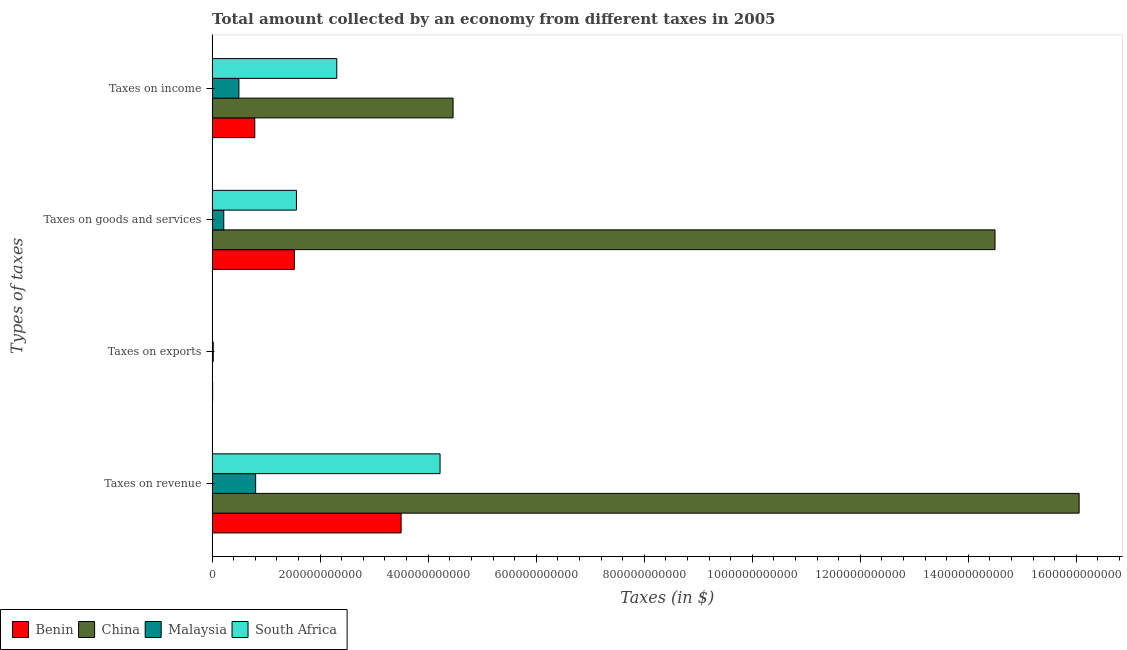How many different coloured bars are there?
Ensure brevity in your answer.  4. Are the number of bars on each tick of the Y-axis equal?
Offer a terse response. No. What is the label of the 1st group of bars from the top?
Give a very brief answer. Taxes on income. What is the amount collected as tax on income in South Africa?
Give a very brief answer. 2.31e+11. Across all countries, what is the maximum amount collected as tax on exports?
Give a very brief answer. 2.08e+09. Across all countries, what is the minimum amount collected as tax on exports?
Offer a very short reply. 0. In which country was the amount collected as tax on exports maximum?
Provide a short and direct response. Malaysia. What is the total amount collected as tax on revenue in the graph?
Your answer should be very brief. 2.46e+12. What is the difference between the amount collected as tax on revenue in South Africa and that in Benin?
Your answer should be compact. 7.21e+1. What is the difference between the amount collected as tax on income in Malaysia and the amount collected as tax on exports in Benin?
Your response must be concise. 4.87e+1. What is the average amount collected as tax on income per country?
Your answer should be compact. 2.01e+11. What is the difference between the amount collected as tax on exports and amount collected as tax on income in Benin?
Provide a succinct answer. -7.81e+1. What is the ratio of the amount collected as tax on revenue in Benin to that in South Africa?
Offer a very short reply. 0.83. Is the amount collected as tax on revenue in China less than that in South Africa?
Your answer should be very brief. No. What is the difference between the highest and the second highest amount collected as tax on revenue?
Your response must be concise. 1.18e+12. What is the difference between the highest and the lowest amount collected as tax on revenue?
Provide a short and direct response. 1.52e+12. Is the sum of the amount collected as tax on income in Benin and South Africa greater than the maximum amount collected as tax on revenue across all countries?
Make the answer very short. No. Is it the case that in every country, the sum of the amount collected as tax on goods and amount collected as tax on income is greater than the sum of amount collected as tax on exports and amount collected as tax on revenue?
Provide a short and direct response. No. Is it the case that in every country, the sum of the amount collected as tax on revenue and amount collected as tax on exports is greater than the amount collected as tax on goods?
Offer a terse response. Yes. What is the difference between two consecutive major ticks on the X-axis?
Offer a terse response. 2.00e+11. Are the values on the major ticks of X-axis written in scientific E-notation?
Provide a succinct answer. No. Does the graph contain grids?
Keep it short and to the point. No. Where does the legend appear in the graph?
Your answer should be very brief. Bottom left. How many legend labels are there?
Your response must be concise. 4. How are the legend labels stacked?
Your answer should be compact. Horizontal. What is the title of the graph?
Your answer should be compact. Total amount collected by an economy from different taxes in 2005. What is the label or title of the X-axis?
Your answer should be compact. Taxes (in $). What is the label or title of the Y-axis?
Provide a short and direct response. Types of taxes. What is the Taxes (in $) in Benin in Taxes on revenue?
Keep it short and to the point. 3.50e+11. What is the Taxes (in $) in China in Taxes on revenue?
Offer a terse response. 1.61e+12. What is the Taxes (in $) in Malaysia in Taxes on revenue?
Provide a succinct answer. 8.06e+1. What is the Taxes (in $) of South Africa in Taxes on revenue?
Keep it short and to the point. 4.22e+11. What is the Taxes (in $) of Benin in Taxes on exports?
Your answer should be compact. 9.19e+08. What is the Taxes (in $) in Malaysia in Taxes on exports?
Provide a succinct answer. 2.08e+09. What is the Taxes (in $) in South Africa in Taxes on exports?
Provide a succinct answer. 1.00e+06. What is the Taxes (in $) in Benin in Taxes on goods and services?
Provide a short and direct response. 1.52e+11. What is the Taxes (in $) of China in Taxes on goods and services?
Offer a terse response. 1.45e+12. What is the Taxes (in $) in Malaysia in Taxes on goods and services?
Your answer should be compact. 2.16e+1. What is the Taxes (in $) in South Africa in Taxes on goods and services?
Your answer should be compact. 1.56e+11. What is the Taxes (in $) of Benin in Taxes on income?
Your answer should be compact. 7.90e+1. What is the Taxes (in $) of China in Taxes on income?
Your answer should be compact. 4.46e+11. What is the Taxes (in $) in Malaysia in Taxes on income?
Make the answer very short. 4.96e+1. What is the Taxes (in $) in South Africa in Taxes on income?
Offer a terse response. 2.31e+11. Across all Types of taxes, what is the maximum Taxes (in $) of Benin?
Your response must be concise. 3.50e+11. Across all Types of taxes, what is the maximum Taxes (in $) of China?
Offer a terse response. 1.61e+12. Across all Types of taxes, what is the maximum Taxes (in $) in Malaysia?
Offer a terse response. 8.06e+1. Across all Types of taxes, what is the maximum Taxes (in $) of South Africa?
Your response must be concise. 4.22e+11. Across all Types of taxes, what is the minimum Taxes (in $) in Benin?
Offer a very short reply. 9.19e+08. Across all Types of taxes, what is the minimum Taxes (in $) of Malaysia?
Provide a succinct answer. 2.08e+09. Across all Types of taxes, what is the minimum Taxes (in $) in South Africa?
Ensure brevity in your answer.  1.00e+06. What is the total Taxes (in $) in Benin in the graph?
Offer a very short reply. 5.82e+11. What is the total Taxes (in $) of China in the graph?
Provide a succinct answer. 3.50e+12. What is the total Taxes (in $) in Malaysia in the graph?
Give a very brief answer. 1.54e+11. What is the total Taxes (in $) in South Africa in the graph?
Your answer should be very brief. 8.09e+11. What is the difference between the Taxes (in $) in Benin in Taxes on revenue and that in Taxes on exports?
Your answer should be compact. 3.49e+11. What is the difference between the Taxes (in $) of Malaysia in Taxes on revenue and that in Taxes on exports?
Provide a succinct answer. 7.85e+1. What is the difference between the Taxes (in $) in South Africa in Taxes on revenue and that in Taxes on exports?
Offer a very short reply. 4.22e+11. What is the difference between the Taxes (in $) in Benin in Taxes on revenue and that in Taxes on goods and services?
Offer a terse response. 1.98e+11. What is the difference between the Taxes (in $) of China in Taxes on revenue and that in Taxes on goods and services?
Your response must be concise. 1.56e+11. What is the difference between the Taxes (in $) in Malaysia in Taxes on revenue and that in Taxes on goods and services?
Provide a short and direct response. 5.90e+1. What is the difference between the Taxes (in $) in South Africa in Taxes on revenue and that in Taxes on goods and services?
Offer a terse response. 2.66e+11. What is the difference between the Taxes (in $) of Benin in Taxes on revenue and that in Taxes on income?
Your answer should be compact. 2.71e+11. What is the difference between the Taxes (in $) of China in Taxes on revenue and that in Taxes on income?
Make the answer very short. 1.16e+12. What is the difference between the Taxes (in $) in Malaysia in Taxes on revenue and that in Taxes on income?
Your answer should be very brief. 3.10e+1. What is the difference between the Taxes (in $) of South Africa in Taxes on revenue and that in Taxes on income?
Ensure brevity in your answer.  1.91e+11. What is the difference between the Taxes (in $) of Benin in Taxes on exports and that in Taxes on goods and services?
Give a very brief answer. -1.51e+11. What is the difference between the Taxes (in $) in Malaysia in Taxes on exports and that in Taxes on goods and services?
Ensure brevity in your answer.  -1.95e+1. What is the difference between the Taxes (in $) of South Africa in Taxes on exports and that in Taxes on goods and services?
Your answer should be compact. -1.56e+11. What is the difference between the Taxes (in $) of Benin in Taxes on exports and that in Taxes on income?
Make the answer very short. -7.81e+1. What is the difference between the Taxes (in $) in Malaysia in Taxes on exports and that in Taxes on income?
Keep it short and to the point. -4.75e+1. What is the difference between the Taxes (in $) of South Africa in Taxes on exports and that in Taxes on income?
Provide a short and direct response. -2.31e+11. What is the difference between the Taxes (in $) of Benin in Taxes on goods and services and that in Taxes on income?
Offer a terse response. 7.32e+1. What is the difference between the Taxes (in $) in China in Taxes on goods and services and that in Taxes on income?
Offer a very short reply. 1.00e+12. What is the difference between the Taxes (in $) in Malaysia in Taxes on goods and services and that in Taxes on income?
Offer a terse response. -2.80e+1. What is the difference between the Taxes (in $) in South Africa in Taxes on goods and services and that in Taxes on income?
Make the answer very short. -7.47e+1. What is the difference between the Taxes (in $) of Benin in Taxes on revenue and the Taxes (in $) of Malaysia in Taxes on exports?
Offer a very short reply. 3.48e+11. What is the difference between the Taxes (in $) of Benin in Taxes on revenue and the Taxes (in $) of South Africa in Taxes on exports?
Provide a succinct answer. 3.50e+11. What is the difference between the Taxes (in $) in China in Taxes on revenue and the Taxes (in $) in Malaysia in Taxes on exports?
Provide a succinct answer. 1.60e+12. What is the difference between the Taxes (in $) of China in Taxes on revenue and the Taxes (in $) of South Africa in Taxes on exports?
Provide a succinct answer. 1.61e+12. What is the difference between the Taxes (in $) of Malaysia in Taxes on revenue and the Taxes (in $) of South Africa in Taxes on exports?
Give a very brief answer. 8.06e+1. What is the difference between the Taxes (in $) of Benin in Taxes on revenue and the Taxes (in $) of China in Taxes on goods and services?
Your answer should be compact. -1.10e+12. What is the difference between the Taxes (in $) in Benin in Taxes on revenue and the Taxes (in $) in Malaysia in Taxes on goods and services?
Make the answer very short. 3.28e+11. What is the difference between the Taxes (in $) of Benin in Taxes on revenue and the Taxes (in $) of South Africa in Taxes on goods and services?
Keep it short and to the point. 1.94e+11. What is the difference between the Taxes (in $) in China in Taxes on revenue and the Taxes (in $) in Malaysia in Taxes on goods and services?
Your answer should be compact. 1.58e+12. What is the difference between the Taxes (in $) in China in Taxes on revenue and the Taxes (in $) in South Africa in Taxes on goods and services?
Give a very brief answer. 1.45e+12. What is the difference between the Taxes (in $) of Malaysia in Taxes on revenue and the Taxes (in $) of South Africa in Taxes on goods and services?
Provide a succinct answer. -7.55e+1. What is the difference between the Taxes (in $) in Benin in Taxes on revenue and the Taxes (in $) in China in Taxes on income?
Keep it short and to the point. -9.62e+1. What is the difference between the Taxes (in $) in Benin in Taxes on revenue and the Taxes (in $) in Malaysia in Taxes on income?
Offer a terse response. 3.00e+11. What is the difference between the Taxes (in $) in Benin in Taxes on revenue and the Taxes (in $) in South Africa in Taxes on income?
Offer a terse response. 1.19e+11. What is the difference between the Taxes (in $) in China in Taxes on revenue and the Taxes (in $) in Malaysia in Taxes on income?
Ensure brevity in your answer.  1.56e+12. What is the difference between the Taxes (in $) of China in Taxes on revenue and the Taxes (in $) of South Africa in Taxes on income?
Your response must be concise. 1.37e+12. What is the difference between the Taxes (in $) in Malaysia in Taxes on revenue and the Taxes (in $) in South Africa in Taxes on income?
Give a very brief answer. -1.50e+11. What is the difference between the Taxes (in $) of Benin in Taxes on exports and the Taxes (in $) of China in Taxes on goods and services?
Your answer should be very brief. -1.45e+12. What is the difference between the Taxes (in $) of Benin in Taxes on exports and the Taxes (in $) of Malaysia in Taxes on goods and services?
Keep it short and to the point. -2.07e+1. What is the difference between the Taxes (in $) in Benin in Taxes on exports and the Taxes (in $) in South Africa in Taxes on goods and services?
Ensure brevity in your answer.  -1.55e+11. What is the difference between the Taxes (in $) in Malaysia in Taxes on exports and the Taxes (in $) in South Africa in Taxes on goods and services?
Make the answer very short. -1.54e+11. What is the difference between the Taxes (in $) of Benin in Taxes on exports and the Taxes (in $) of China in Taxes on income?
Your response must be concise. -4.45e+11. What is the difference between the Taxes (in $) of Benin in Taxes on exports and the Taxes (in $) of Malaysia in Taxes on income?
Offer a very short reply. -4.87e+1. What is the difference between the Taxes (in $) of Benin in Taxes on exports and the Taxes (in $) of South Africa in Taxes on income?
Your response must be concise. -2.30e+11. What is the difference between the Taxes (in $) of Malaysia in Taxes on exports and the Taxes (in $) of South Africa in Taxes on income?
Your answer should be very brief. -2.29e+11. What is the difference between the Taxes (in $) of Benin in Taxes on goods and services and the Taxes (in $) of China in Taxes on income?
Your answer should be very brief. -2.94e+11. What is the difference between the Taxes (in $) of Benin in Taxes on goods and services and the Taxes (in $) of Malaysia in Taxes on income?
Provide a short and direct response. 1.03e+11. What is the difference between the Taxes (in $) in Benin in Taxes on goods and services and the Taxes (in $) in South Africa in Taxes on income?
Keep it short and to the point. -7.86e+1. What is the difference between the Taxes (in $) of China in Taxes on goods and services and the Taxes (in $) of Malaysia in Taxes on income?
Give a very brief answer. 1.40e+12. What is the difference between the Taxes (in $) of China in Taxes on goods and services and the Taxes (in $) of South Africa in Taxes on income?
Provide a short and direct response. 1.22e+12. What is the difference between the Taxes (in $) of Malaysia in Taxes on goods and services and the Taxes (in $) of South Africa in Taxes on income?
Your answer should be compact. -2.09e+11. What is the average Taxes (in $) in Benin per Types of taxes?
Your answer should be very brief. 1.46e+11. What is the average Taxes (in $) in China per Types of taxes?
Keep it short and to the point. 8.75e+11. What is the average Taxes (in $) in Malaysia per Types of taxes?
Offer a terse response. 3.85e+1. What is the average Taxes (in $) of South Africa per Types of taxes?
Keep it short and to the point. 2.02e+11. What is the difference between the Taxes (in $) in Benin and Taxes (in $) in China in Taxes on revenue?
Ensure brevity in your answer.  -1.26e+12. What is the difference between the Taxes (in $) of Benin and Taxes (in $) of Malaysia in Taxes on revenue?
Provide a succinct answer. 2.69e+11. What is the difference between the Taxes (in $) of Benin and Taxes (in $) of South Africa in Taxes on revenue?
Offer a terse response. -7.21e+1. What is the difference between the Taxes (in $) in China and Taxes (in $) in Malaysia in Taxes on revenue?
Ensure brevity in your answer.  1.52e+12. What is the difference between the Taxes (in $) of China and Taxes (in $) of South Africa in Taxes on revenue?
Offer a very short reply. 1.18e+12. What is the difference between the Taxes (in $) of Malaysia and Taxes (in $) of South Africa in Taxes on revenue?
Provide a succinct answer. -3.41e+11. What is the difference between the Taxes (in $) in Benin and Taxes (in $) in Malaysia in Taxes on exports?
Offer a very short reply. -1.17e+09. What is the difference between the Taxes (in $) of Benin and Taxes (in $) of South Africa in Taxes on exports?
Make the answer very short. 9.18e+08. What is the difference between the Taxes (in $) of Malaysia and Taxes (in $) of South Africa in Taxes on exports?
Your response must be concise. 2.08e+09. What is the difference between the Taxes (in $) in Benin and Taxes (in $) in China in Taxes on goods and services?
Your answer should be very brief. -1.30e+12. What is the difference between the Taxes (in $) of Benin and Taxes (in $) of Malaysia in Taxes on goods and services?
Your response must be concise. 1.31e+11. What is the difference between the Taxes (in $) in Benin and Taxes (in $) in South Africa in Taxes on goods and services?
Provide a short and direct response. -3.89e+09. What is the difference between the Taxes (in $) in China and Taxes (in $) in Malaysia in Taxes on goods and services?
Your response must be concise. 1.43e+12. What is the difference between the Taxes (in $) of China and Taxes (in $) of South Africa in Taxes on goods and services?
Ensure brevity in your answer.  1.29e+12. What is the difference between the Taxes (in $) of Malaysia and Taxes (in $) of South Africa in Taxes on goods and services?
Ensure brevity in your answer.  -1.35e+11. What is the difference between the Taxes (in $) in Benin and Taxes (in $) in China in Taxes on income?
Your answer should be very brief. -3.67e+11. What is the difference between the Taxes (in $) of Benin and Taxes (in $) of Malaysia in Taxes on income?
Offer a terse response. 2.94e+1. What is the difference between the Taxes (in $) of Benin and Taxes (in $) of South Africa in Taxes on income?
Keep it short and to the point. -1.52e+11. What is the difference between the Taxes (in $) of China and Taxes (in $) of Malaysia in Taxes on income?
Offer a very short reply. 3.97e+11. What is the difference between the Taxes (in $) in China and Taxes (in $) in South Africa in Taxes on income?
Offer a very short reply. 2.15e+11. What is the difference between the Taxes (in $) of Malaysia and Taxes (in $) of South Africa in Taxes on income?
Provide a succinct answer. -1.81e+11. What is the ratio of the Taxes (in $) of Benin in Taxes on revenue to that in Taxes on exports?
Provide a short and direct response. 380.65. What is the ratio of the Taxes (in $) in Malaysia in Taxes on revenue to that in Taxes on exports?
Offer a terse response. 38.65. What is the ratio of the Taxes (in $) in South Africa in Taxes on revenue to that in Taxes on exports?
Ensure brevity in your answer.  4.22e+05. What is the ratio of the Taxes (in $) in Benin in Taxes on revenue to that in Taxes on goods and services?
Offer a terse response. 2.3. What is the ratio of the Taxes (in $) in China in Taxes on revenue to that in Taxes on goods and services?
Your response must be concise. 1.11. What is the ratio of the Taxes (in $) of Malaysia in Taxes on revenue to that in Taxes on goods and services?
Your response must be concise. 3.73. What is the ratio of the Taxes (in $) of South Africa in Taxes on revenue to that in Taxes on goods and services?
Your answer should be very brief. 2.7. What is the ratio of the Taxes (in $) in Benin in Taxes on revenue to that in Taxes on income?
Your answer should be very brief. 4.43. What is the ratio of the Taxes (in $) of China in Taxes on revenue to that in Taxes on income?
Your response must be concise. 3.6. What is the ratio of the Taxes (in $) in Malaysia in Taxes on revenue to that in Taxes on income?
Provide a short and direct response. 1.62. What is the ratio of the Taxes (in $) of South Africa in Taxes on revenue to that in Taxes on income?
Provide a succinct answer. 1.83. What is the ratio of the Taxes (in $) in Benin in Taxes on exports to that in Taxes on goods and services?
Keep it short and to the point. 0.01. What is the ratio of the Taxes (in $) in Malaysia in Taxes on exports to that in Taxes on goods and services?
Provide a short and direct response. 0.1. What is the ratio of the Taxes (in $) of Benin in Taxes on exports to that in Taxes on income?
Offer a very short reply. 0.01. What is the ratio of the Taxes (in $) of Malaysia in Taxes on exports to that in Taxes on income?
Give a very brief answer. 0.04. What is the ratio of the Taxes (in $) in Benin in Taxes on goods and services to that in Taxes on income?
Offer a very short reply. 1.93. What is the ratio of the Taxes (in $) in China in Taxes on goods and services to that in Taxes on income?
Offer a very short reply. 3.25. What is the ratio of the Taxes (in $) in Malaysia in Taxes on goods and services to that in Taxes on income?
Offer a terse response. 0.44. What is the ratio of the Taxes (in $) of South Africa in Taxes on goods and services to that in Taxes on income?
Offer a very short reply. 0.68. What is the difference between the highest and the second highest Taxes (in $) of Benin?
Offer a terse response. 1.98e+11. What is the difference between the highest and the second highest Taxes (in $) of China?
Offer a terse response. 1.56e+11. What is the difference between the highest and the second highest Taxes (in $) in Malaysia?
Keep it short and to the point. 3.10e+1. What is the difference between the highest and the second highest Taxes (in $) of South Africa?
Make the answer very short. 1.91e+11. What is the difference between the highest and the lowest Taxes (in $) in Benin?
Your answer should be very brief. 3.49e+11. What is the difference between the highest and the lowest Taxes (in $) in China?
Your response must be concise. 1.61e+12. What is the difference between the highest and the lowest Taxes (in $) in Malaysia?
Ensure brevity in your answer.  7.85e+1. What is the difference between the highest and the lowest Taxes (in $) in South Africa?
Offer a terse response. 4.22e+11. 